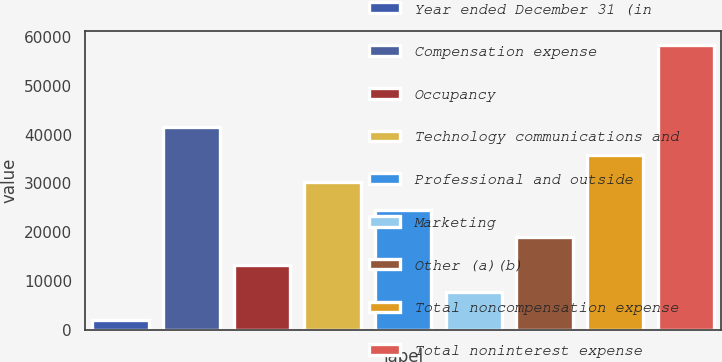<chart> <loc_0><loc_0><loc_500><loc_500><bar_chart><fcel>Year ended December 31 (in<fcel>Compensation expense<fcel>Occupancy<fcel>Technology communications and<fcel>Professional and outside<fcel>Marketing<fcel>Other (a)(b)<fcel>Total noncompensation expense<fcel>Total noninterest expense<nl><fcel>2017<fcel>41508.9<fcel>13300.4<fcel>30225.5<fcel>24583.8<fcel>7658.7<fcel>18942.1<fcel>35867.2<fcel>58434<nl></chart> 